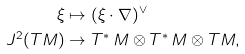<formula> <loc_0><loc_0><loc_500><loc_500>\xi & \mapsto ( \xi \cdot \nabla ) ^ { \vee } \\ J ^ { 2 } ( T M ) & \rightarrow T ^ { * } \, M \otimes T ^ { * } \, M \otimes T M ,</formula> 